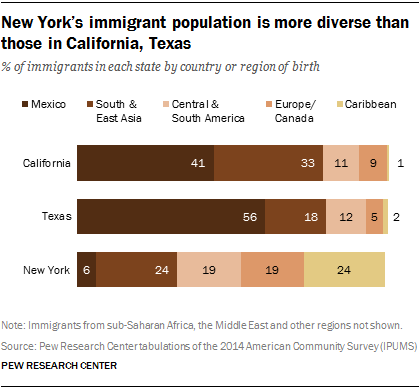Specify some key components in this picture. Five colors are present on the bar. The sum of a t-distribution between Texas and California is 97. 